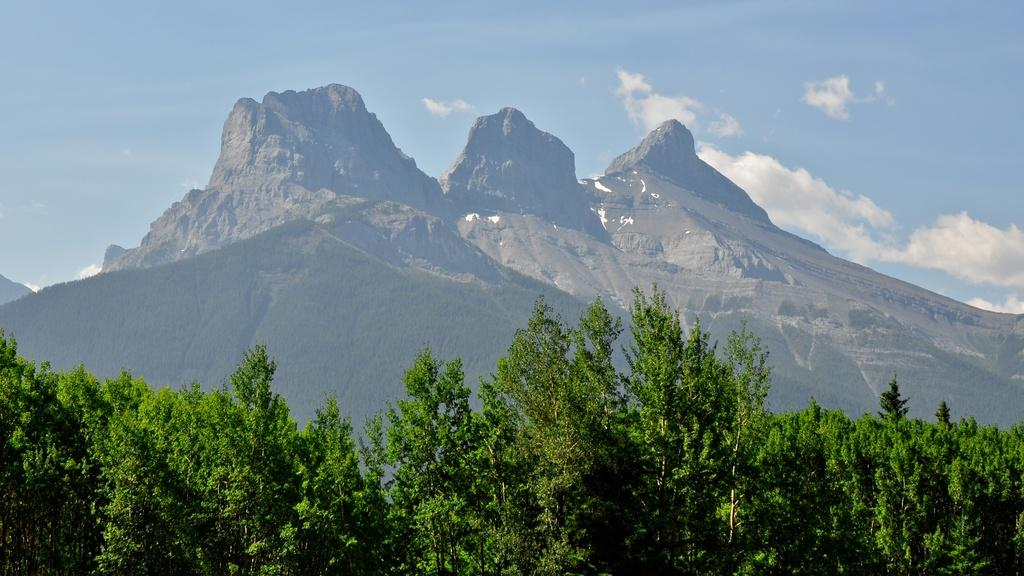What color is the sky in the image? The sky is blue and visible at the top of the image. What geographical features can be seen in the middle of the image? There are mountain ranges in the middle of the image. What type of vegetation is present at the bottom of the image? Green trees are present at the bottom of the image. What is the texture of the chin in the image? There is no chin present in the image. What thought is being expressed by the trees in the image? Trees do not express thoughts, so this question cannot be answered. 